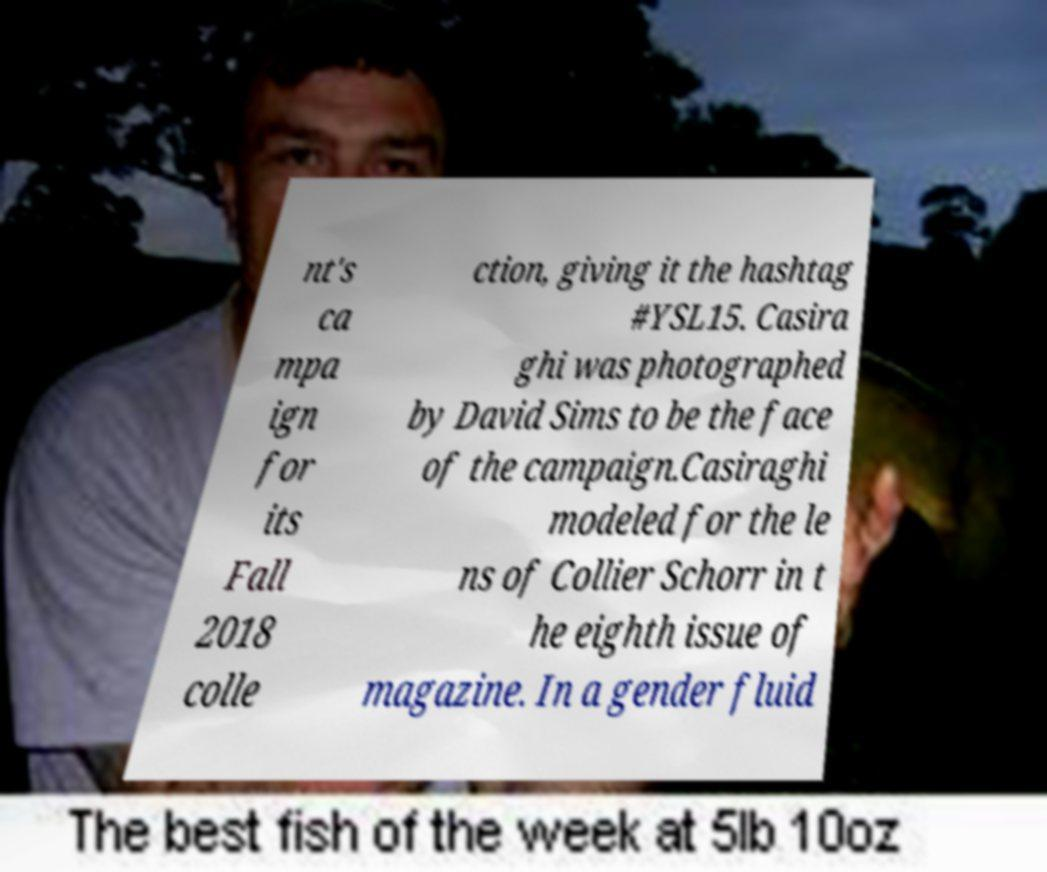For documentation purposes, I need the text within this image transcribed. Could you provide that? nt's ca mpa ign for its Fall 2018 colle ction, giving it the hashtag #YSL15. Casira ghi was photographed by David Sims to be the face of the campaign.Casiraghi modeled for the le ns of Collier Schorr in t he eighth issue of magazine. In a gender fluid 